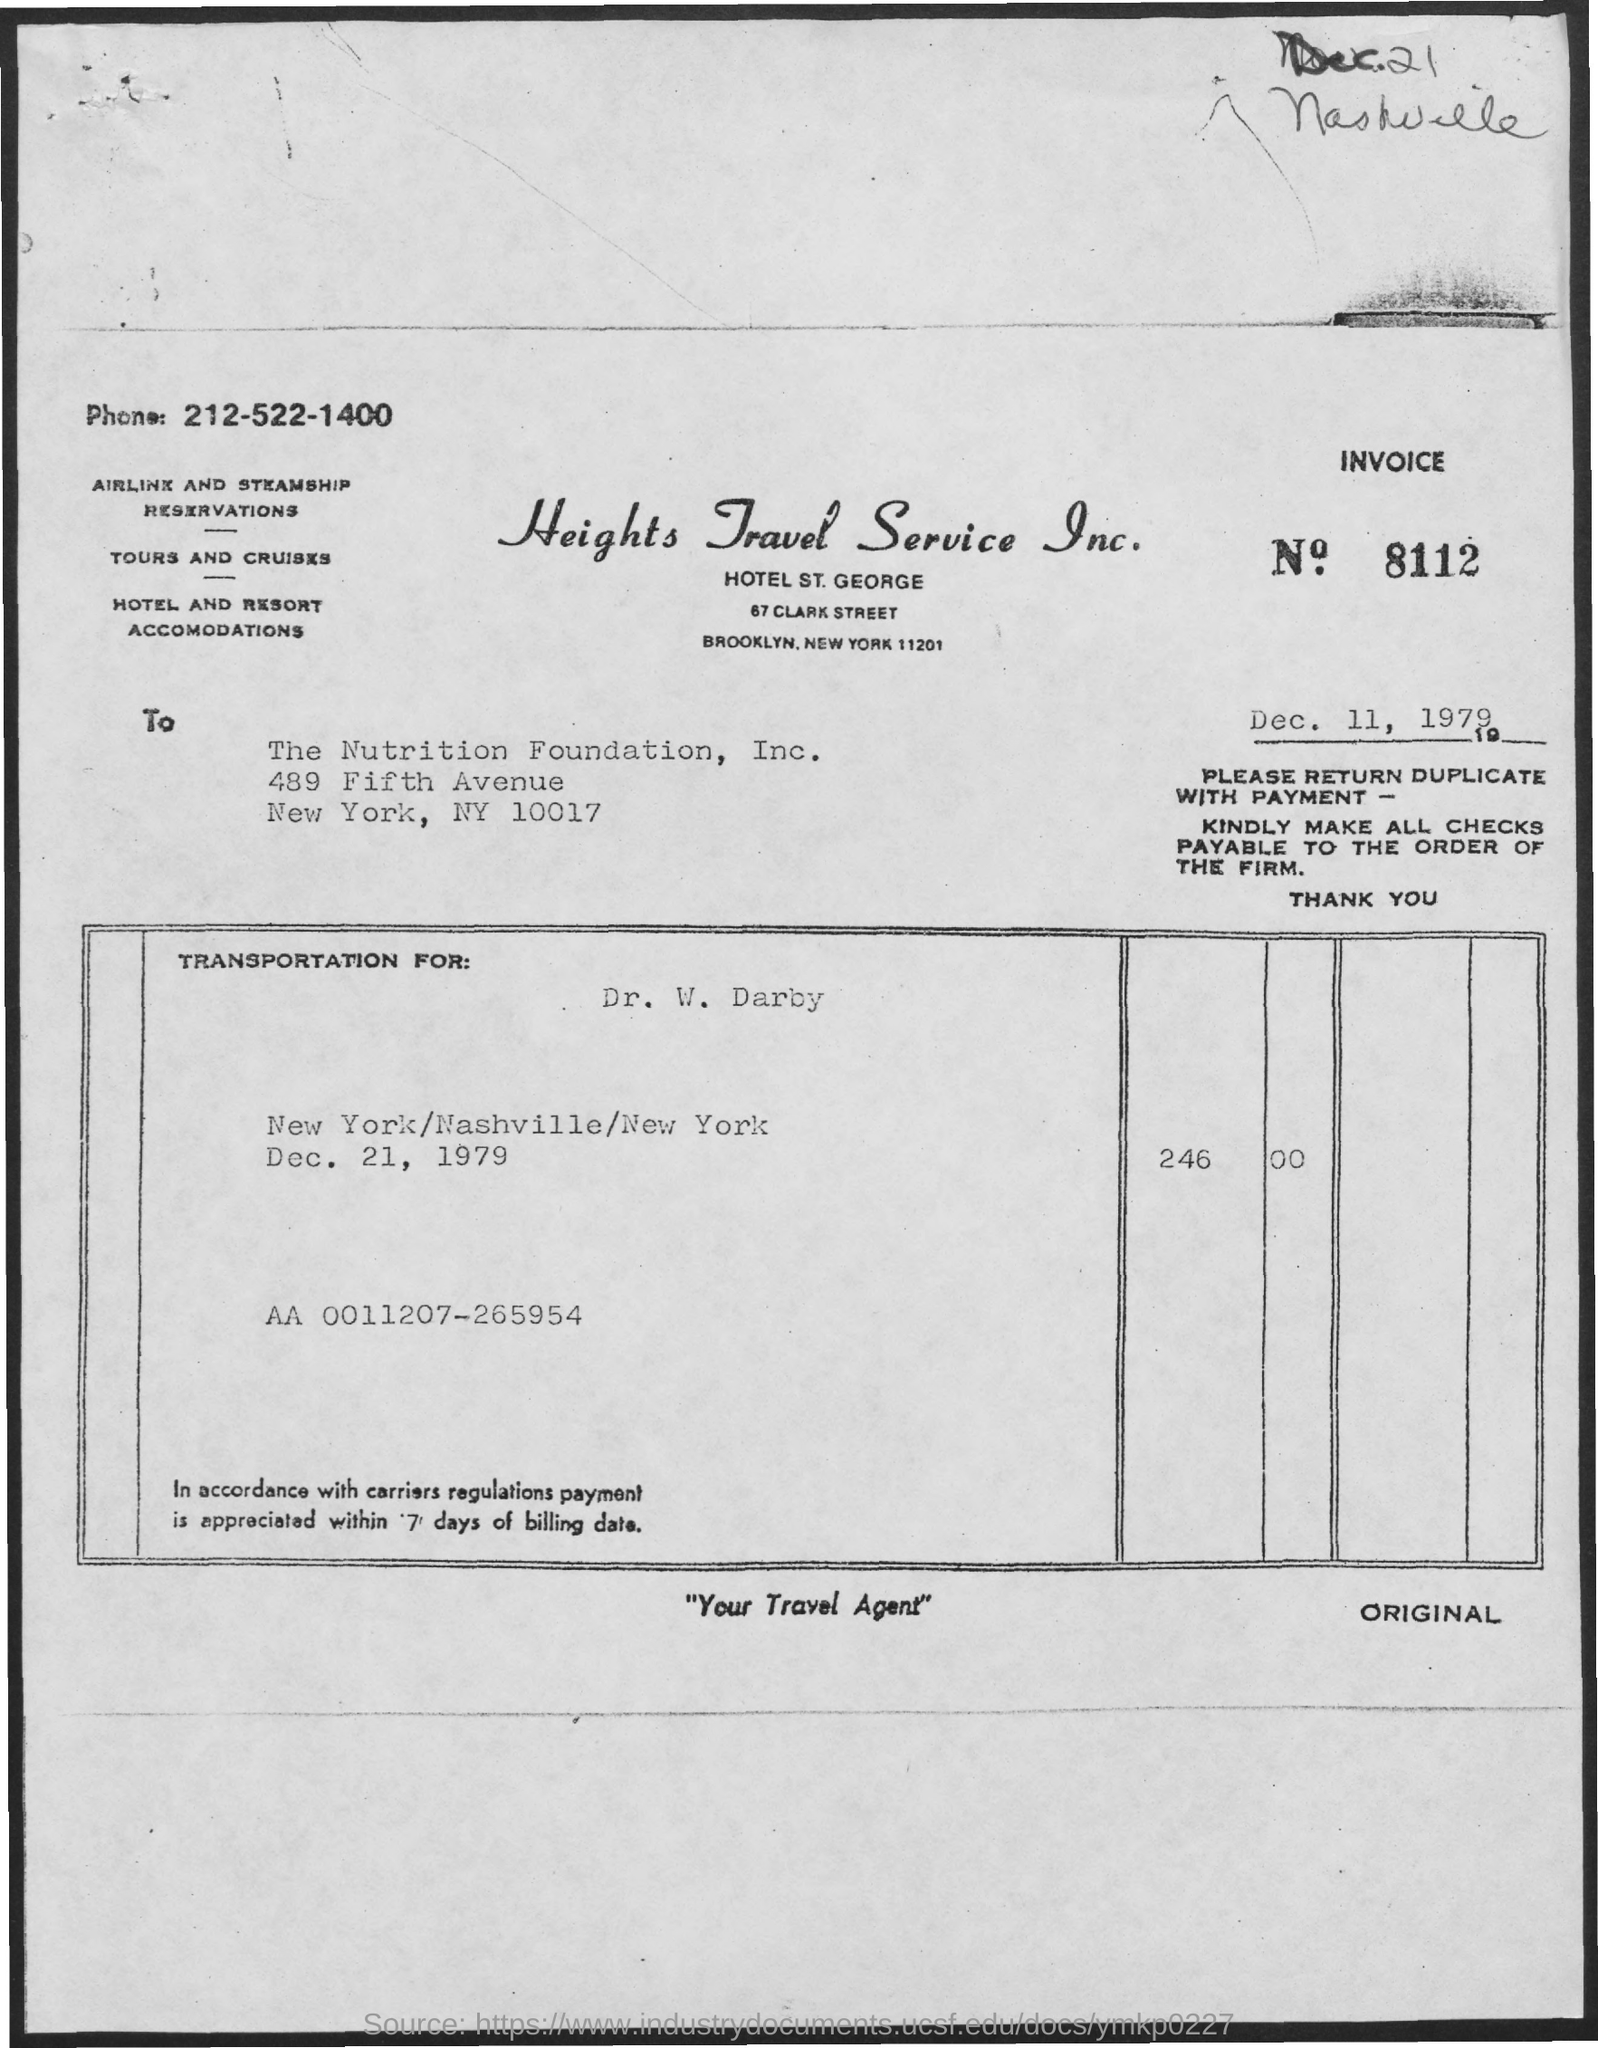Specify some key components in this picture. The invoice is being raised by Heights Travel Service Inc. The invoice number mentioned in this document is 8112. The invoice amount for transportation for Dr. W. Darby on December 21, 1979, was $246. Heights Travel Service Inc. can be contacted by phone at 212-522-1400. The issued date of the invoice is December 11, 1979. 